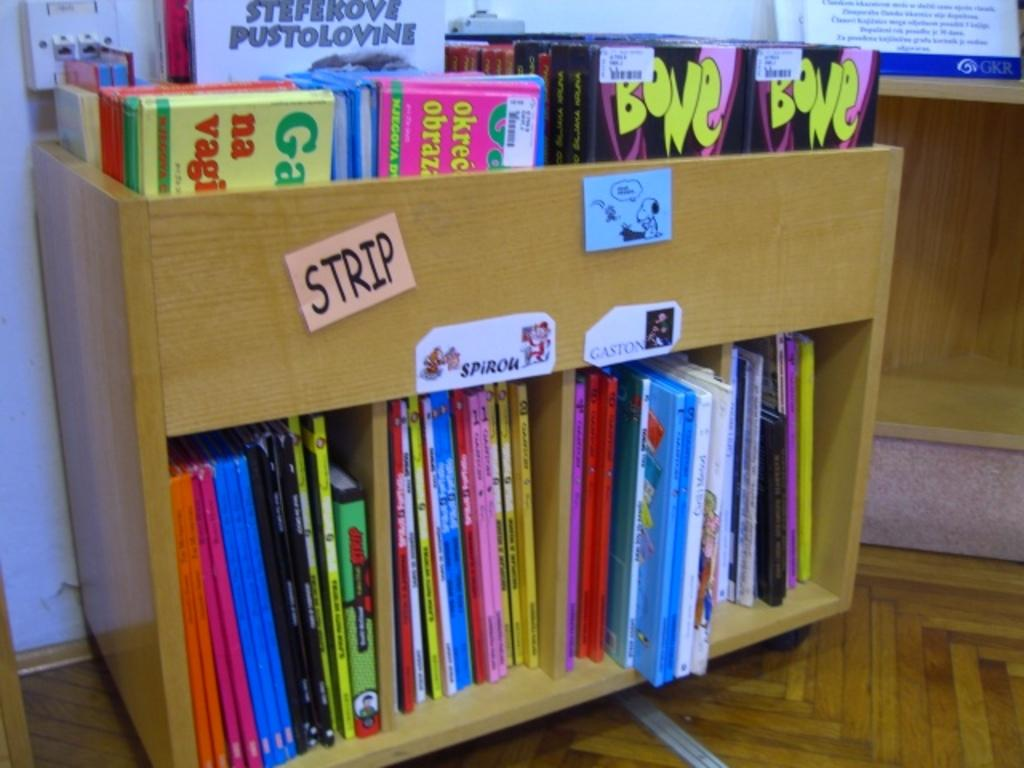<image>
Write a terse but informative summary of the picture. A wooden cart full of children's books including one called Bone. 